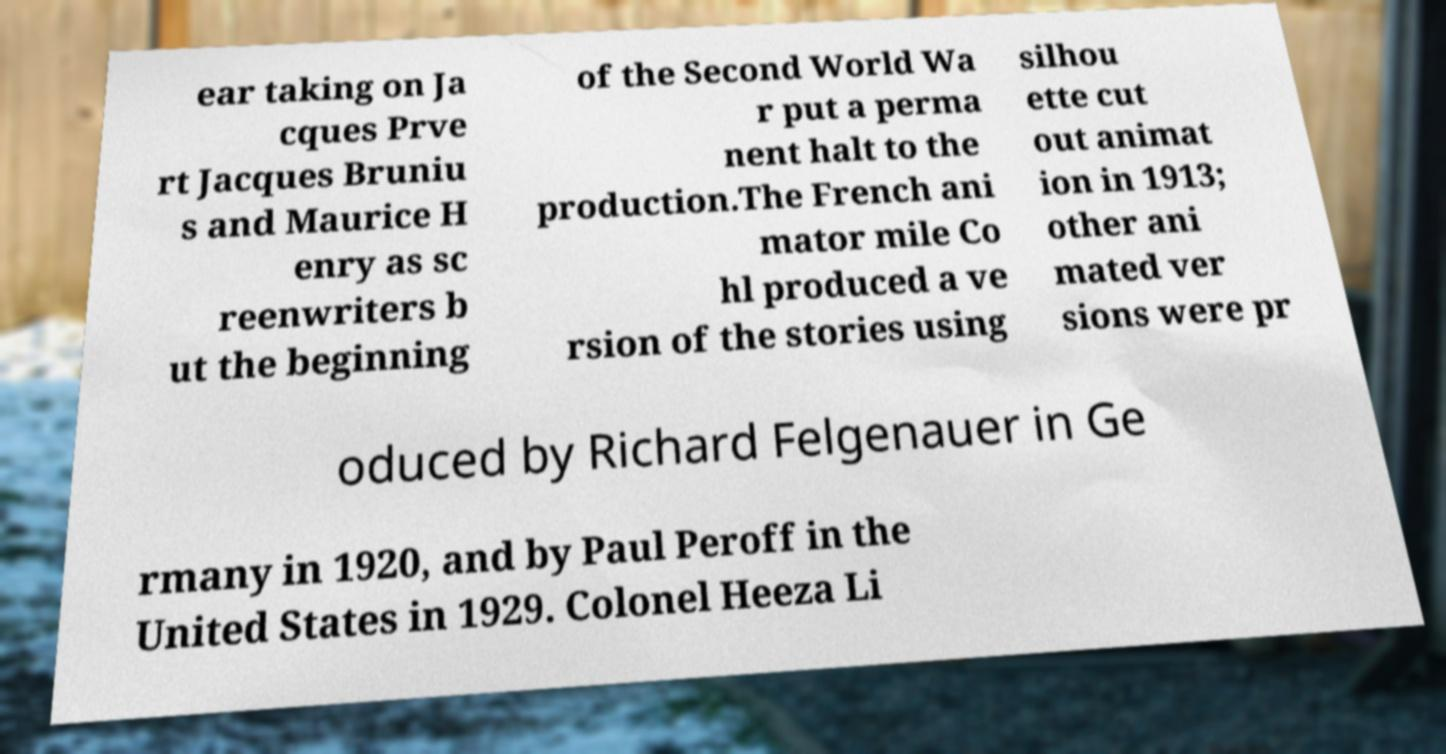Can you accurately transcribe the text from the provided image for me? ear taking on Ja cques Prve rt Jacques Bruniu s and Maurice H enry as sc reenwriters b ut the beginning of the Second World Wa r put a perma nent halt to the production.The French ani mator mile Co hl produced a ve rsion of the stories using silhou ette cut out animat ion in 1913; other ani mated ver sions were pr oduced by Richard Felgenauer in Ge rmany in 1920, and by Paul Peroff in the United States in 1929. Colonel Heeza Li 